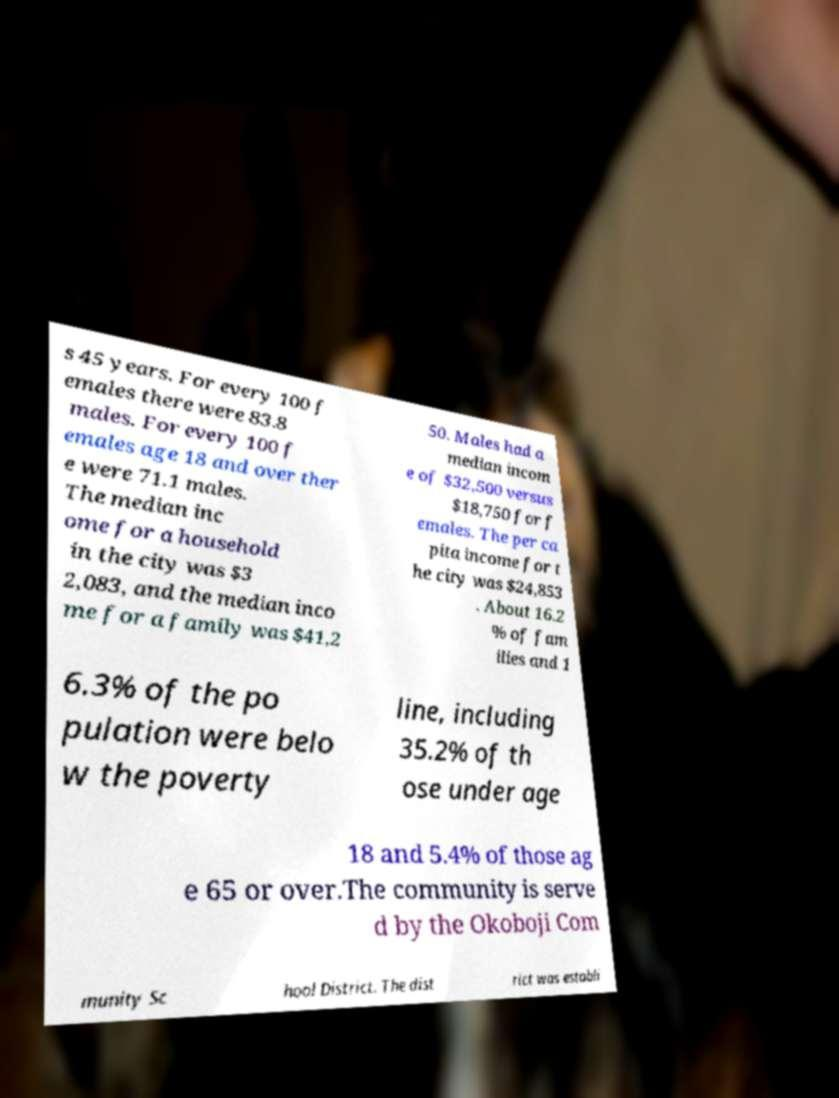Could you assist in decoding the text presented in this image and type it out clearly? s 45 years. For every 100 f emales there were 83.8 males. For every 100 f emales age 18 and over ther e were 71.1 males. The median inc ome for a household in the city was $3 2,083, and the median inco me for a family was $41,2 50. Males had a median incom e of $32,500 versus $18,750 for f emales. The per ca pita income for t he city was $24,853 . About 16.2 % of fam ilies and 1 6.3% of the po pulation were belo w the poverty line, including 35.2% of th ose under age 18 and 5.4% of those ag e 65 or over.The community is serve d by the Okoboji Com munity Sc hool District. The dist rict was establi 